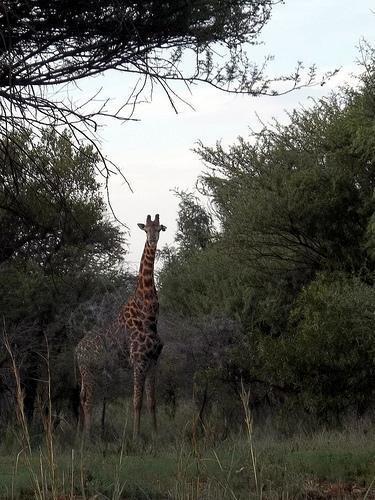How many giraffes?
Give a very brief answer. 1. 